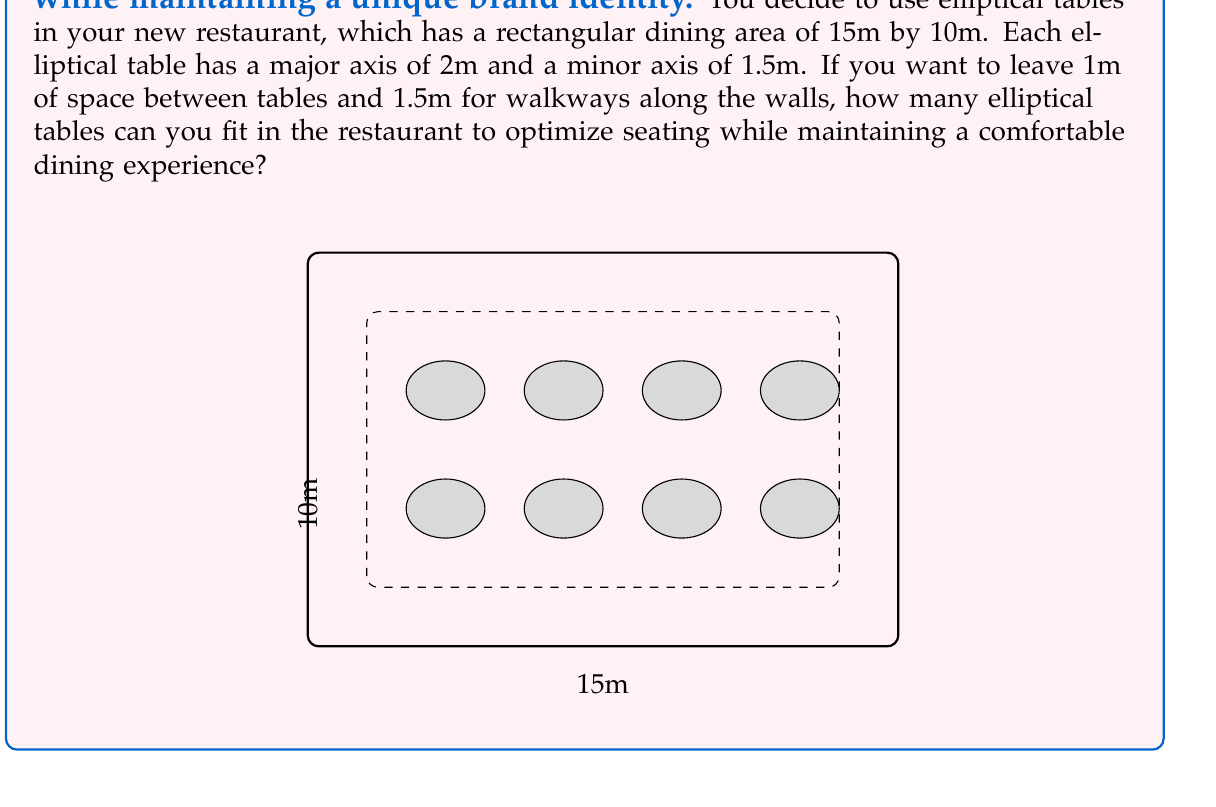Provide a solution to this math problem. Let's approach this problem step-by-step:

1) First, calculate the usable area:
   - Length: $15m - (2 \times 1.5m) = 12m$
   - Width: $10m - (2 \times 1.5m) = 7m$
   - Usable area: $12m \times 7m = 84m^2$

2) Each table occupies an area:
   - Table area: $\pi \times \frac{major axis}{2} \times \frac{minor axis}{2} = \pi \times 1 \times 0.75 = 2.356m^2$

3) Space needed for each table including the 1m buffer:
   - Length: $2m + 1m = 3m$
   - Width: $1.5m + 1m = 2.5m$
   - Total area per table: $3m \times 2.5m = 7.5m^2$

4) Number of tables that can fit length-wise:
   $\lfloor \frac{12m}{3m} \rfloor = 4$ tables

5) Number of tables that can fit width-wise:
   $\lfloor \frac{7m}{2.5m} \rfloor = 2$ tables

6) Total number of tables:
   $4 \times 2 = 8$ tables

Therefore, you can fit 8 elliptical tables in the restaurant while maintaining the required spacing.
Answer: 8 tables 